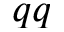<formula> <loc_0><loc_0><loc_500><loc_500>q q</formula> 